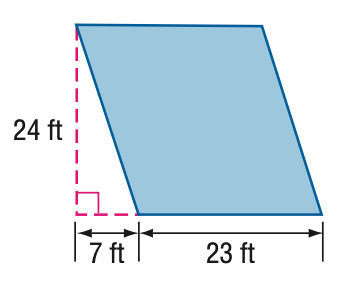Answer the mathemtical geometry problem and directly provide the correct option letter.
Question: Find the perimeter of the parallelogram.
Choices: A: 94 B: 96 C: 98 D: 100 B 